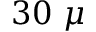Convert formula to latex. <formula><loc_0><loc_0><loc_500><loc_500>3 0 \mu</formula> 